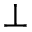Convert formula to latex. <formula><loc_0><loc_0><loc_500><loc_500>\perp</formula> 